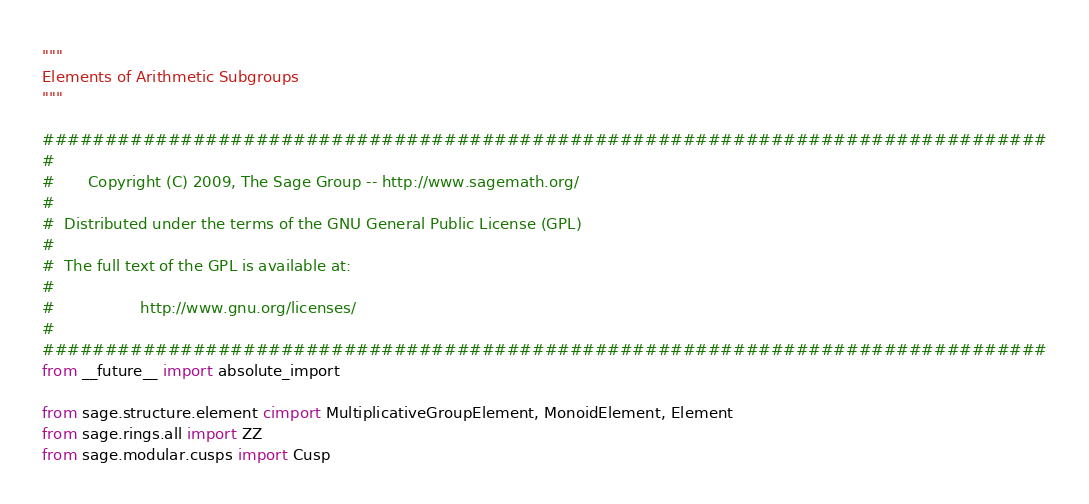<code> <loc_0><loc_0><loc_500><loc_500><_Cython_>"""
Elements of Arithmetic Subgroups
"""

################################################################################
#
#       Copyright (C) 2009, The Sage Group -- http://www.sagemath.org/
#
#  Distributed under the terms of the GNU General Public License (GPL)
#
#  The full text of the GPL is available at:
#
#                  http://www.gnu.org/licenses/
#
################################################################################
from __future__ import absolute_import

from sage.structure.element cimport MultiplicativeGroupElement, MonoidElement, Element
from sage.rings.all import ZZ
from sage.modular.cusps import Cusp
</code> 